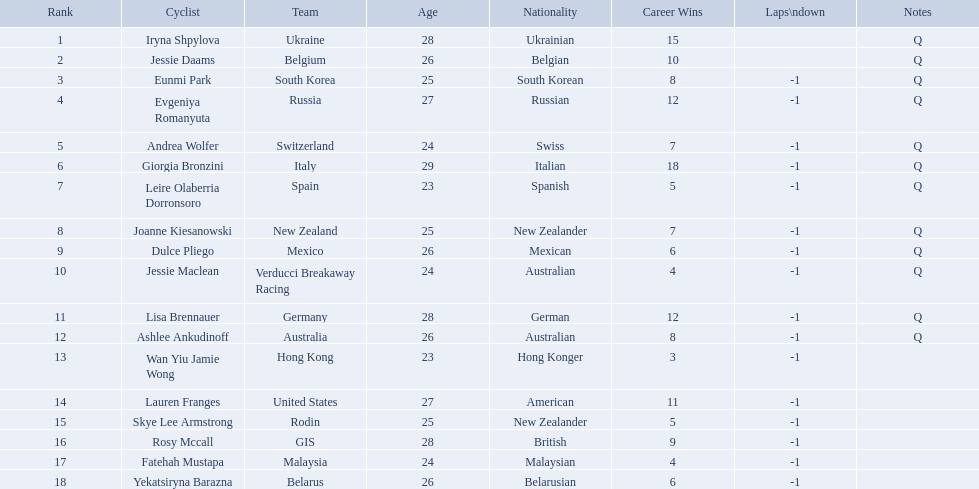Who competed in the race? Iryna Shpylova, Jessie Daams, Eunmi Park, Evgeniya Romanyuta, Andrea Wolfer, Giorgia Bronzini, Leire Olaberria Dorronsoro, Joanne Kiesanowski, Dulce Pliego, Jessie Maclean, Lisa Brennauer, Ashlee Ankudinoff, Wan Yiu Jamie Wong, Lauren Franges, Skye Lee Armstrong, Rosy Mccall, Fatehah Mustapa, Yekatsiryna Barazna. Who ranked highest in the race? Iryna Shpylova. 